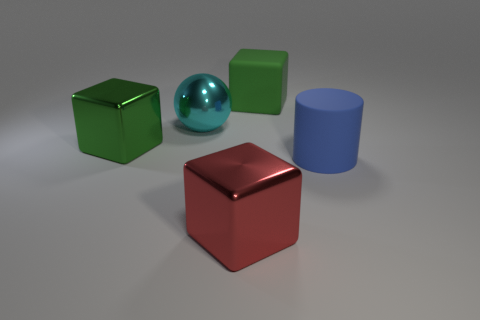Are there any other things that are the same shape as the big blue rubber thing?
Ensure brevity in your answer.  No. How many large metal blocks have the same color as the large rubber cube?
Give a very brief answer. 1. Is the large ball the same color as the large cylinder?
Provide a short and direct response. No. What number of objects are either big rubber things that are on the right side of the big green rubber object or big green shiny cylinders?
Offer a terse response. 1. The rubber object that is in front of the large green cube that is on the left side of the metal block right of the cyan sphere is what color?
Make the answer very short. Blue. There is another object that is made of the same material as the blue thing; what color is it?
Give a very brief answer. Green. What number of tiny green spheres are the same material as the red thing?
Offer a terse response. 0. There is a rubber object that is left of the blue thing; is its size the same as the large green shiny thing?
Provide a short and direct response. Yes. The shiny ball that is the same size as the cylinder is what color?
Provide a short and direct response. Cyan. What number of cubes are in front of the big cylinder?
Offer a terse response. 1. 